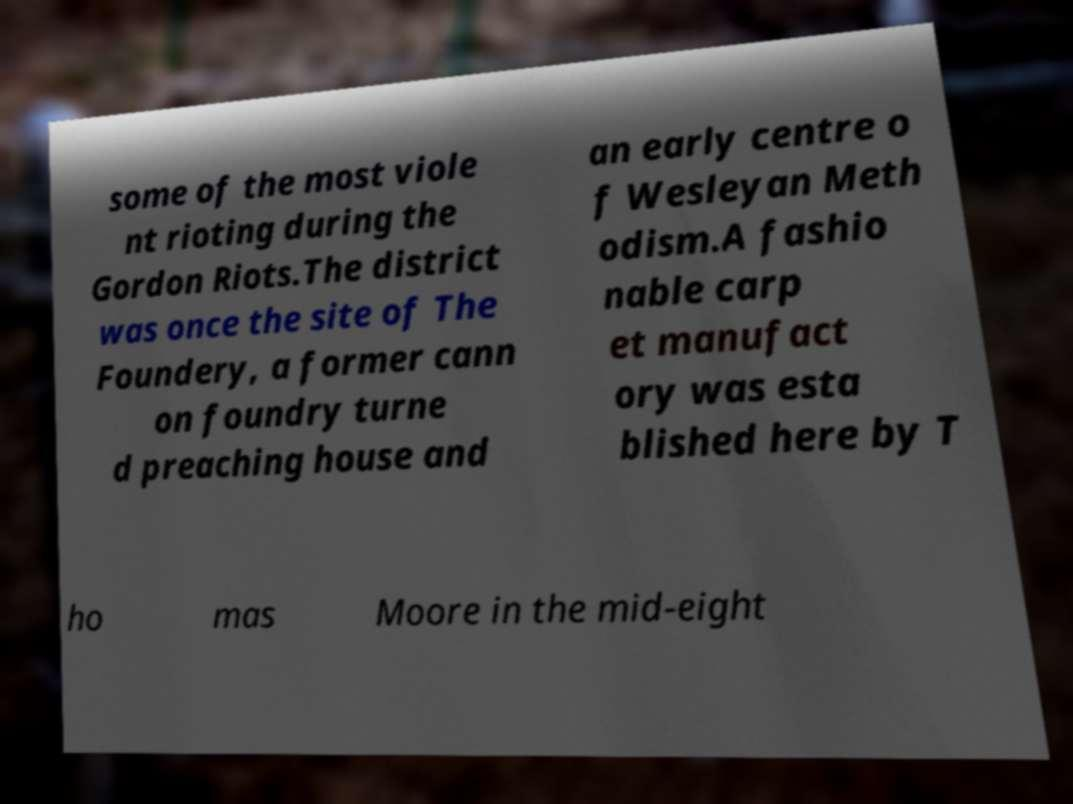For documentation purposes, I need the text within this image transcribed. Could you provide that? some of the most viole nt rioting during the Gordon Riots.The district was once the site of The Foundery, a former cann on foundry turne d preaching house and an early centre o f Wesleyan Meth odism.A fashio nable carp et manufact ory was esta blished here by T ho mas Moore in the mid-eight 